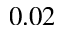<formula> <loc_0><loc_0><loc_500><loc_500>0 . 0 2</formula> 